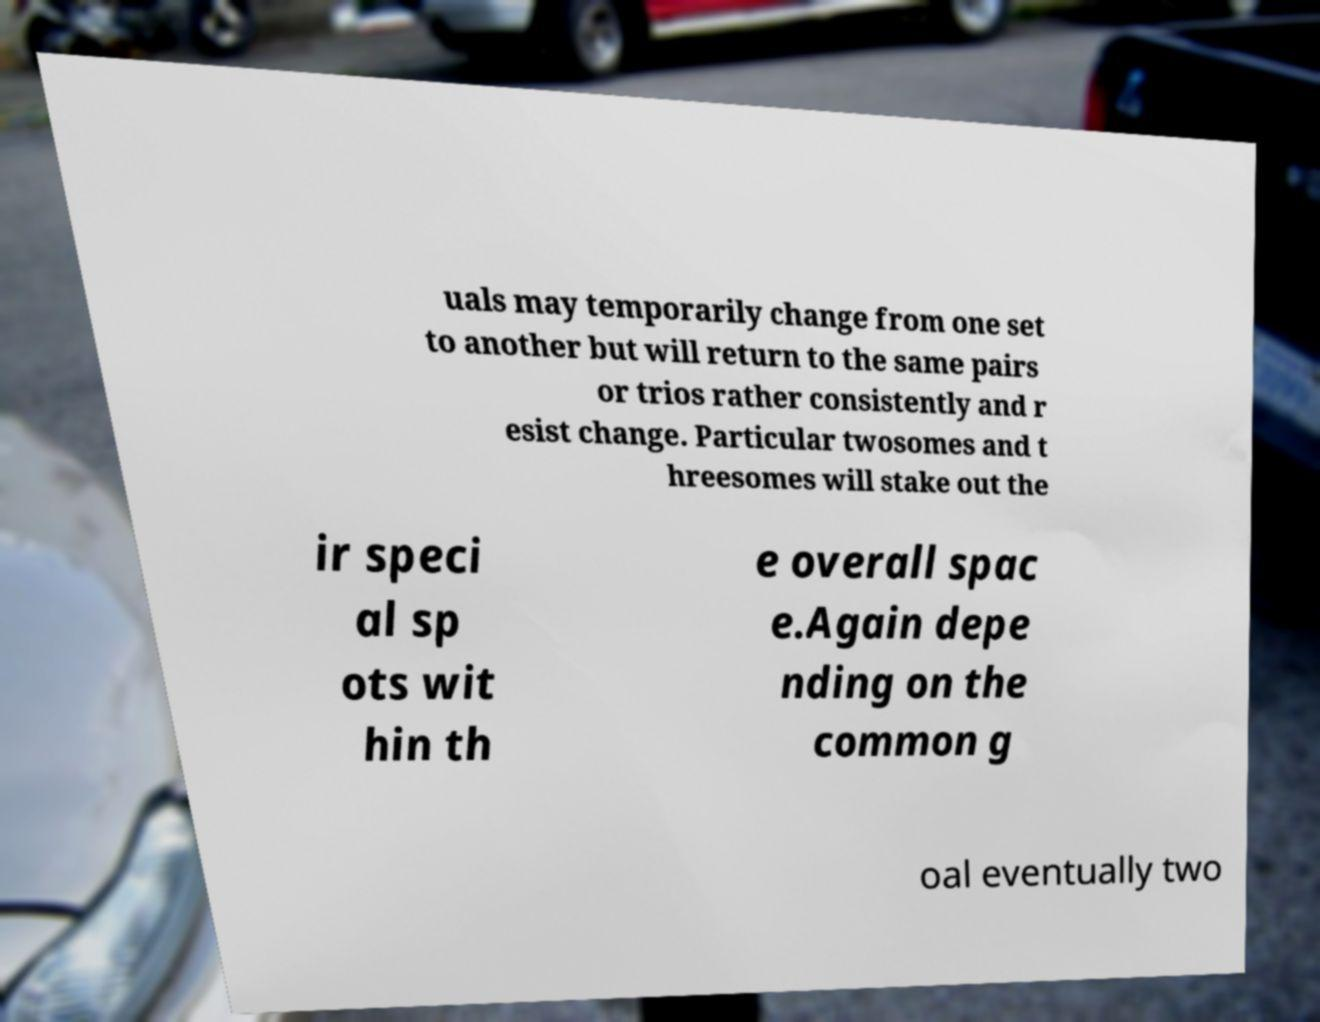Can you read and provide the text displayed in the image?This photo seems to have some interesting text. Can you extract and type it out for me? uals may temporarily change from one set to another but will return to the same pairs or trios rather consistently and r esist change. Particular twosomes and t hreesomes will stake out the ir speci al sp ots wit hin th e overall spac e.Again depe nding on the common g oal eventually two 